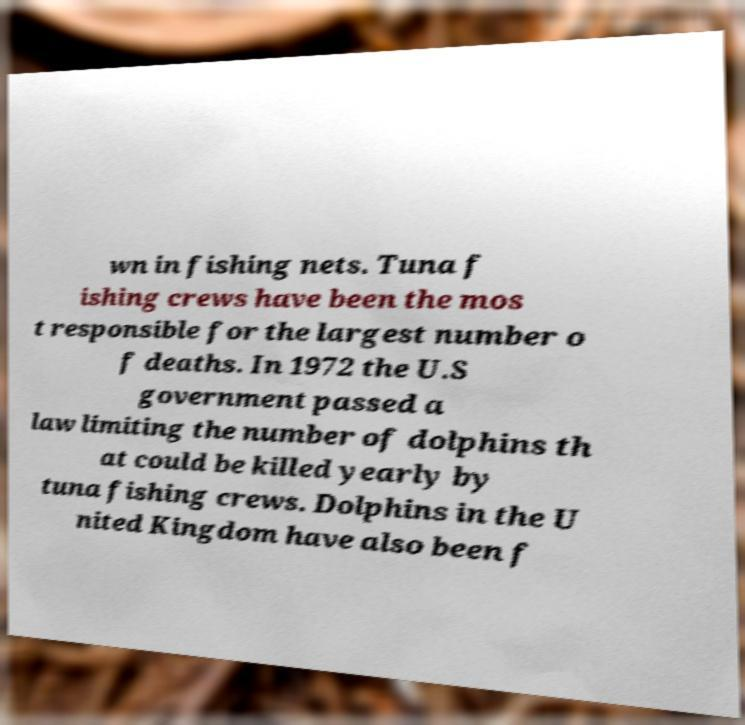Please identify and transcribe the text found in this image. wn in fishing nets. Tuna f ishing crews have been the mos t responsible for the largest number o f deaths. In 1972 the U.S government passed a law limiting the number of dolphins th at could be killed yearly by tuna fishing crews. Dolphins in the U nited Kingdom have also been f 